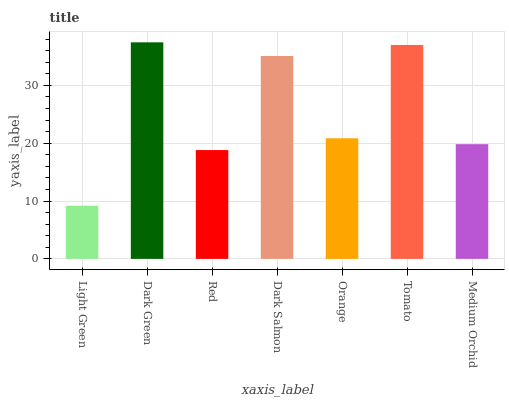Is Light Green the minimum?
Answer yes or no. Yes. Is Dark Green the maximum?
Answer yes or no. Yes. Is Red the minimum?
Answer yes or no. No. Is Red the maximum?
Answer yes or no. No. Is Dark Green greater than Red?
Answer yes or no. Yes. Is Red less than Dark Green?
Answer yes or no. Yes. Is Red greater than Dark Green?
Answer yes or no. No. Is Dark Green less than Red?
Answer yes or no. No. Is Orange the high median?
Answer yes or no. Yes. Is Orange the low median?
Answer yes or no. Yes. Is Dark Salmon the high median?
Answer yes or no. No. Is Medium Orchid the low median?
Answer yes or no. No. 